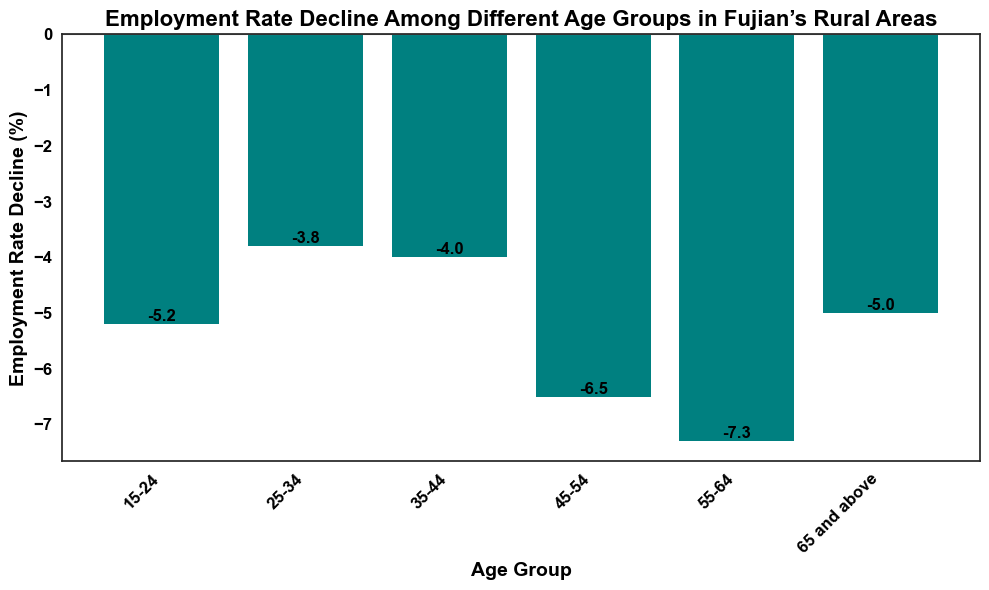What is the age group with the highest employment rate decline? The bars represent the employment rate decline for different age groups. The age group with the tallest or most negative bar has the highest decline. The bar for the 55-64 age group is the longest, indicating the greatest decline.
Answer: 55-64 What is the total employment rate decline for the age groups 25-34 and 35-44? The employment rate decline for ages 25-34 is -3.8%, and for 35-44 is -4.0%. Adding these values gives -3.8 + (-4.0) = -7.8.
Answer: -7.8% How much greater is the employment rate decline for the 45-54 age group compared to the 25-34 age group? The decline for the 45-54 age group is -6.5% and for the 25-34 age group is -3.8%. The difference is calculated as -6.5 - (-3.8) = -2.7.
Answer: 2.7% Which age group shows a steeper employment rate decline compared to the 65 and above age group? By comparing the bar heights visually, the age groups 55-64 and 45-54 have taller bars than the 65 and above group, indicating a steeper decline.
Answer: 55-64 and 45-54 What is the average employment rate decline across all age groups? Sum up all the declines: -5.2 - 3.8 - 4.0 - 6.5 - 7.3 - 5.0 = -31.8. There are 6 age groups, so dividing the total by 6 gives -31.8 / 6 = -5.3.
Answer: -5.3% Which age groups have an employment rate decline close to the average decline? The average decline is -5.3%. Comparing all age groups, 15-24 (-5.2%) and 65 and above (-5.0%) are closest to the average decline.
Answer: 15-24 and 65 and above 